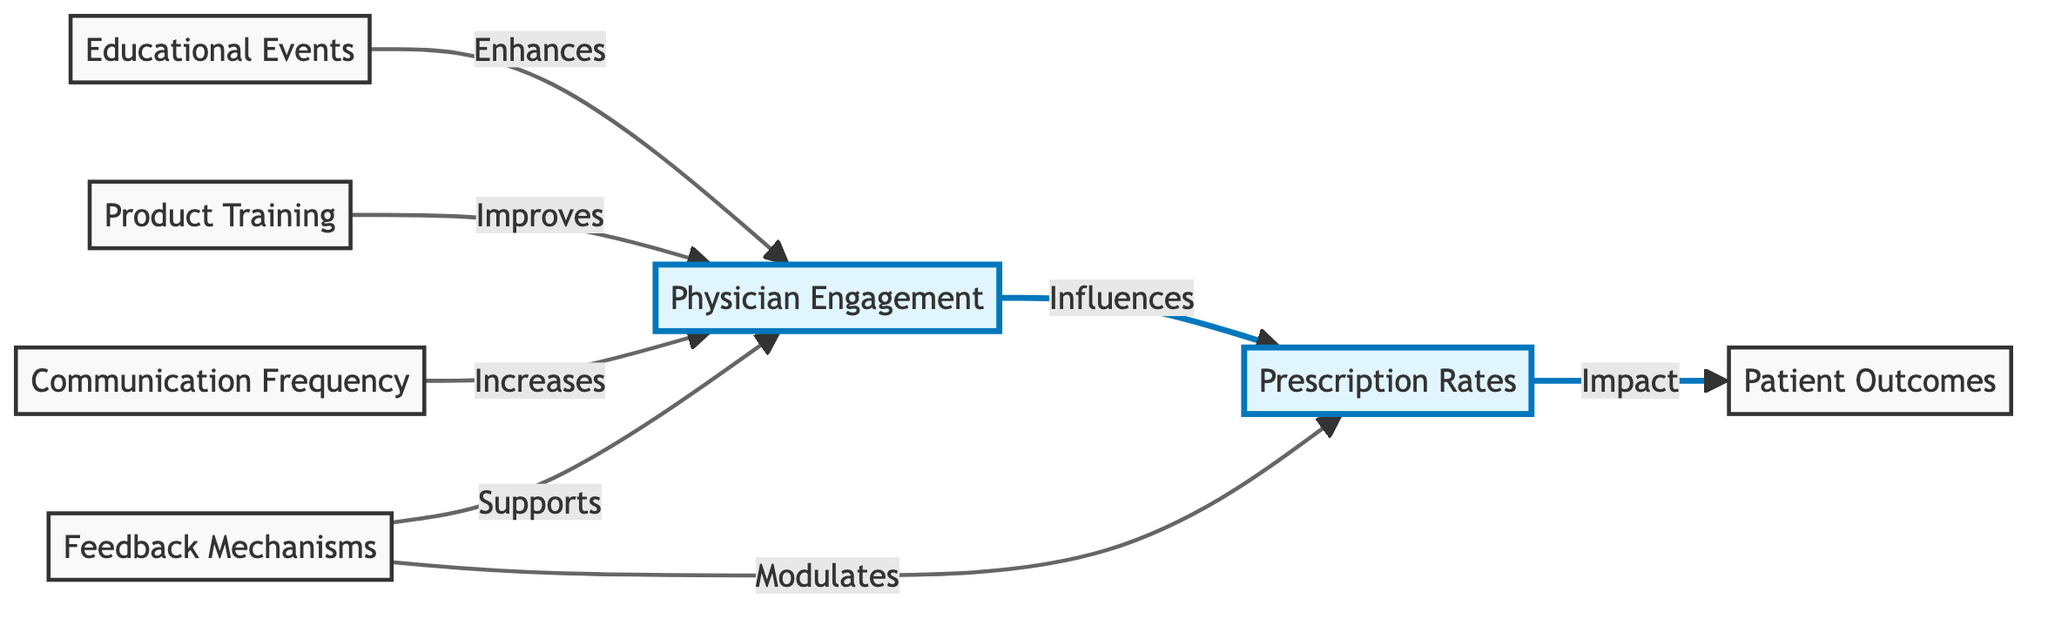What is the primary node representing the start of the relationship? The primary node at the beginning of the diagram is "Physician Engagement." It is depicted as having connections to other nodes that detail factors enhancing physician engagement, leading to prescription rates.
Answer: Physician Engagement How many nodes are connected to "Physician Engagement"? The node "Physician Engagement" has four connections leading from it, representing factors contributing to its enhancement like educational events, product training, communication frequency, and feedback mechanisms.
Answer: Four Which node directly influences prescription rates? "Physician Engagement" is the node that directly influences prescription rates according to the flow of the diagram, showing that improved engagement leads to better prescription rates.
Answer: Physician Engagement What two factors enhance physician engagement? The diagram shows that "Educational Events" and "Product Training" are both factors that enhance Physician Engagement, indicating their significance in increasing engagement levels.
Answer: Educational Events, Product Training How does feedback mechanisms relate to prescription rates? The diagram illustrates that feedback mechanisms support physician engagement and modulate prescription rates. This indicates that feedback plays a role in both engaging physicians and influencing their prescription behavior.
Answer: Supports and modulates What is the final outcome influenced by prescription rates? The final outcome indicated in the diagram influenced directly by prescription rates is "Patient Outcomes." This signifies that the prescriptions given by engaged physicians ultimately affect patient health results.
Answer: Patient Outcomes Which node is influenced by communication frequency? The node influenced by communication frequency is "Physician Engagement," which indicates that increased communication enhances the level of engagement that physicians have.
Answer: Physician Engagement What type of arrows indicate a stronger influence on the relationships? The thicker blue arrows in the diagram indicate stronger influence or importance in the relationships between the nodes, particularly between physician engagement and prescription rates.
Answer: Thicker blue arrows What role does "Patient Outcomes" have in the diagram? "Patient Outcomes" is its own node in the diagram that represents the end result of the relationship chain, indicating that effective prescription practices resulting from physician engagement lead to improved patient outcomes.
Answer: End result 